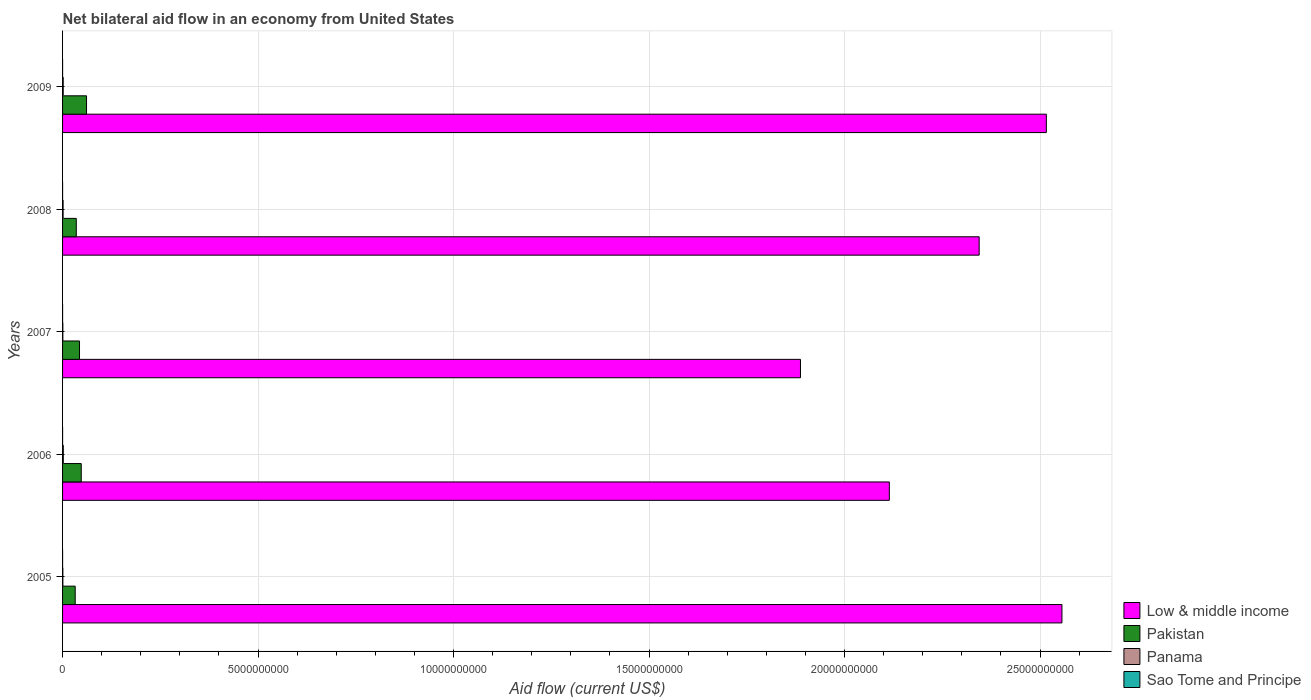Are the number of bars on each tick of the Y-axis equal?
Your answer should be very brief. Yes. How many bars are there on the 3rd tick from the top?
Keep it short and to the point. 4. What is the label of the 4th group of bars from the top?
Ensure brevity in your answer.  2006. In how many cases, is the number of bars for a given year not equal to the number of legend labels?
Your answer should be very brief. 0. What is the net bilateral aid flow in Pakistan in 2006?
Your answer should be very brief. 4.78e+08. Across all years, what is the maximum net bilateral aid flow in Sao Tome and Principe?
Make the answer very short. 4.60e+05. Across all years, what is the minimum net bilateral aid flow in Panama?
Offer a very short reply. 7.28e+06. In which year was the net bilateral aid flow in Sao Tome and Principe maximum?
Your answer should be compact. 2006. What is the total net bilateral aid flow in Sao Tome and Principe in the graph?
Your answer should be very brief. 1.44e+06. What is the difference between the net bilateral aid flow in Panama in 2005 and that in 2008?
Provide a short and direct response. -6.16e+06. What is the difference between the net bilateral aid flow in Low & middle income in 2009 and the net bilateral aid flow in Pakistan in 2008?
Make the answer very short. 2.48e+1. What is the average net bilateral aid flow in Low & middle income per year?
Offer a terse response. 2.28e+1. In the year 2005, what is the difference between the net bilateral aid flow in Pakistan and net bilateral aid flow in Panama?
Provide a succinct answer. 3.16e+08. In how many years, is the net bilateral aid flow in Pakistan greater than 21000000000 US$?
Keep it short and to the point. 0. What is the ratio of the net bilateral aid flow in Pakistan in 2006 to that in 2008?
Offer a very short reply. 1.36. Is the net bilateral aid flow in Panama in 2007 less than that in 2009?
Ensure brevity in your answer.  Yes. What is the difference between the highest and the second highest net bilateral aid flow in Pakistan?
Offer a terse response. 1.35e+08. In how many years, is the net bilateral aid flow in Low & middle income greater than the average net bilateral aid flow in Low & middle income taken over all years?
Your answer should be very brief. 3. What does the 1st bar from the top in 2009 represents?
Your response must be concise. Sao Tome and Principe. What does the 1st bar from the bottom in 2006 represents?
Your response must be concise. Low & middle income. Are all the bars in the graph horizontal?
Your response must be concise. Yes. How many years are there in the graph?
Provide a succinct answer. 5. What is the title of the graph?
Offer a very short reply. Net bilateral aid flow in an economy from United States. Does "Romania" appear as one of the legend labels in the graph?
Make the answer very short. No. What is the label or title of the Y-axis?
Give a very brief answer. Years. What is the Aid flow (current US$) of Low & middle income in 2005?
Your response must be concise. 2.56e+1. What is the Aid flow (current US$) of Pakistan in 2005?
Make the answer very short. 3.23e+08. What is the Aid flow (current US$) of Panama in 2005?
Provide a short and direct response. 7.50e+06. What is the Aid flow (current US$) in Sao Tome and Principe in 2005?
Your response must be concise. 1.40e+05. What is the Aid flow (current US$) in Low & middle income in 2006?
Ensure brevity in your answer.  2.11e+1. What is the Aid flow (current US$) of Pakistan in 2006?
Your answer should be compact. 4.78e+08. What is the Aid flow (current US$) of Panama in 2006?
Give a very brief answer. 1.87e+07. What is the Aid flow (current US$) in Low & middle income in 2007?
Give a very brief answer. 1.89e+1. What is the Aid flow (current US$) in Pakistan in 2007?
Offer a terse response. 4.34e+08. What is the Aid flow (current US$) in Panama in 2007?
Make the answer very short. 7.28e+06. What is the Aid flow (current US$) of Sao Tome and Principe in 2007?
Provide a short and direct response. 2.30e+05. What is the Aid flow (current US$) in Low & middle income in 2008?
Provide a short and direct response. 2.34e+1. What is the Aid flow (current US$) of Pakistan in 2008?
Give a very brief answer. 3.51e+08. What is the Aid flow (current US$) of Panama in 2008?
Provide a succinct answer. 1.37e+07. What is the Aid flow (current US$) in Low & middle income in 2009?
Offer a very short reply. 2.52e+1. What is the Aid flow (current US$) of Pakistan in 2009?
Your answer should be compact. 6.13e+08. What is the Aid flow (current US$) in Panama in 2009?
Provide a short and direct response. 1.67e+07. Across all years, what is the maximum Aid flow (current US$) in Low & middle income?
Ensure brevity in your answer.  2.56e+1. Across all years, what is the maximum Aid flow (current US$) of Pakistan?
Offer a terse response. 6.13e+08. Across all years, what is the maximum Aid flow (current US$) in Panama?
Your answer should be compact. 1.87e+07. Across all years, what is the minimum Aid flow (current US$) in Low & middle income?
Ensure brevity in your answer.  1.89e+1. Across all years, what is the minimum Aid flow (current US$) in Pakistan?
Make the answer very short. 3.23e+08. Across all years, what is the minimum Aid flow (current US$) of Panama?
Give a very brief answer. 7.28e+06. What is the total Aid flow (current US$) of Low & middle income in the graph?
Your answer should be very brief. 1.14e+11. What is the total Aid flow (current US$) in Pakistan in the graph?
Provide a succinct answer. 2.20e+09. What is the total Aid flow (current US$) of Panama in the graph?
Make the answer very short. 6.38e+07. What is the total Aid flow (current US$) in Sao Tome and Principe in the graph?
Give a very brief answer. 1.44e+06. What is the difference between the Aid flow (current US$) in Low & middle income in 2005 and that in 2006?
Your answer should be very brief. 4.41e+09. What is the difference between the Aid flow (current US$) of Pakistan in 2005 and that in 2006?
Ensure brevity in your answer.  -1.55e+08. What is the difference between the Aid flow (current US$) in Panama in 2005 and that in 2006?
Provide a short and direct response. -1.12e+07. What is the difference between the Aid flow (current US$) in Sao Tome and Principe in 2005 and that in 2006?
Make the answer very short. -3.20e+05. What is the difference between the Aid flow (current US$) of Low & middle income in 2005 and that in 2007?
Ensure brevity in your answer.  6.69e+09. What is the difference between the Aid flow (current US$) of Pakistan in 2005 and that in 2007?
Keep it short and to the point. -1.10e+08. What is the difference between the Aid flow (current US$) of Panama in 2005 and that in 2007?
Keep it short and to the point. 2.20e+05. What is the difference between the Aid flow (current US$) in Low & middle income in 2005 and that in 2008?
Your answer should be very brief. 2.12e+09. What is the difference between the Aid flow (current US$) of Pakistan in 2005 and that in 2008?
Make the answer very short. -2.76e+07. What is the difference between the Aid flow (current US$) of Panama in 2005 and that in 2008?
Your answer should be very brief. -6.16e+06. What is the difference between the Aid flow (current US$) of Low & middle income in 2005 and that in 2009?
Ensure brevity in your answer.  3.99e+08. What is the difference between the Aid flow (current US$) of Pakistan in 2005 and that in 2009?
Provide a short and direct response. -2.90e+08. What is the difference between the Aid flow (current US$) of Panama in 2005 and that in 2009?
Provide a short and direct response. -9.16e+06. What is the difference between the Aid flow (current US$) in Low & middle income in 2006 and that in 2007?
Provide a succinct answer. 2.27e+09. What is the difference between the Aid flow (current US$) in Pakistan in 2006 and that in 2007?
Ensure brevity in your answer.  4.42e+07. What is the difference between the Aid flow (current US$) of Panama in 2006 and that in 2007?
Provide a short and direct response. 1.14e+07. What is the difference between the Aid flow (current US$) of Low & middle income in 2006 and that in 2008?
Provide a succinct answer. -2.30e+09. What is the difference between the Aid flow (current US$) of Pakistan in 2006 and that in 2008?
Provide a succinct answer. 1.27e+08. What is the difference between the Aid flow (current US$) in Panama in 2006 and that in 2008?
Offer a very short reply. 5.07e+06. What is the difference between the Aid flow (current US$) in Low & middle income in 2006 and that in 2009?
Your answer should be very brief. -4.02e+09. What is the difference between the Aid flow (current US$) of Pakistan in 2006 and that in 2009?
Your answer should be compact. -1.35e+08. What is the difference between the Aid flow (current US$) of Panama in 2006 and that in 2009?
Provide a short and direct response. 2.07e+06. What is the difference between the Aid flow (current US$) of Sao Tome and Principe in 2006 and that in 2009?
Give a very brief answer. 6.00e+04. What is the difference between the Aid flow (current US$) of Low & middle income in 2007 and that in 2008?
Your response must be concise. -4.57e+09. What is the difference between the Aid flow (current US$) of Pakistan in 2007 and that in 2008?
Keep it short and to the point. 8.29e+07. What is the difference between the Aid flow (current US$) of Panama in 2007 and that in 2008?
Your response must be concise. -6.38e+06. What is the difference between the Aid flow (current US$) of Low & middle income in 2007 and that in 2009?
Your answer should be compact. -6.29e+09. What is the difference between the Aid flow (current US$) in Pakistan in 2007 and that in 2009?
Your answer should be compact. -1.79e+08. What is the difference between the Aid flow (current US$) of Panama in 2007 and that in 2009?
Your answer should be compact. -9.38e+06. What is the difference between the Aid flow (current US$) in Sao Tome and Principe in 2007 and that in 2009?
Provide a succinct answer. -1.70e+05. What is the difference between the Aid flow (current US$) in Low & middle income in 2008 and that in 2009?
Offer a very short reply. -1.72e+09. What is the difference between the Aid flow (current US$) of Pakistan in 2008 and that in 2009?
Your answer should be compact. -2.62e+08. What is the difference between the Aid flow (current US$) in Panama in 2008 and that in 2009?
Provide a succinct answer. -3.00e+06. What is the difference between the Aid flow (current US$) in Low & middle income in 2005 and the Aid flow (current US$) in Pakistan in 2006?
Provide a succinct answer. 2.51e+1. What is the difference between the Aid flow (current US$) of Low & middle income in 2005 and the Aid flow (current US$) of Panama in 2006?
Give a very brief answer. 2.55e+1. What is the difference between the Aid flow (current US$) of Low & middle income in 2005 and the Aid flow (current US$) of Sao Tome and Principe in 2006?
Make the answer very short. 2.56e+1. What is the difference between the Aid flow (current US$) in Pakistan in 2005 and the Aid flow (current US$) in Panama in 2006?
Your response must be concise. 3.04e+08. What is the difference between the Aid flow (current US$) of Pakistan in 2005 and the Aid flow (current US$) of Sao Tome and Principe in 2006?
Keep it short and to the point. 3.23e+08. What is the difference between the Aid flow (current US$) in Panama in 2005 and the Aid flow (current US$) in Sao Tome and Principe in 2006?
Give a very brief answer. 7.04e+06. What is the difference between the Aid flow (current US$) of Low & middle income in 2005 and the Aid flow (current US$) of Pakistan in 2007?
Ensure brevity in your answer.  2.51e+1. What is the difference between the Aid flow (current US$) of Low & middle income in 2005 and the Aid flow (current US$) of Panama in 2007?
Your answer should be very brief. 2.56e+1. What is the difference between the Aid flow (current US$) of Low & middle income in 2005 and the Aid flow (current US$) of Sao Tome and Principe in 2007?
Keep it short and to the point. 2.56e+1. What is the difference between the Aid flow (current US$) in Pakistan in 2005 and the Aid flow (current US$) in Panama in 2007?
Offer a terse response. 3.16e+08. What is the difference between the Aid flow (current US$) of Pakistan in 2005 and the Aid flow (current US$) of Sao Tome and Principe in 2007?
Offer a very short reply. 3.23e+08. What is the difference between the Aid flow (current US$) in Panama in 2005 and the Aid flow (current US$) in Sao Tome and Principe in 2007?
Your answer should be very brief. 7.27e+06. What is the difference between the Aid flow (current US$) of Low & middle income in 2005 and the Aid flow (current US$) of Pakistan in 2008?
Your response must be concise. 2.52e+1. What is the difference between the Aid flow (current US$) of Low & middle income in 2005 and the Aid flow (current US$) of Panama in 2008?
Provide a succinct answer. 2.55e+1. What is the difference between the Aid flow (current US$) of Low & middle income in 2005 and the Aid flow (current US$) of Sao Tome and Principe in 2008?
Your answer should be compact. 2.56e+1. What is the difference between the Aid flow (current US$) of Pakistan in 2005 and the Aid flow (current US$) of Panama in 2008?
Offer a terse response. 3.09e+08. What is the difference between the Aid flow (current US$) in Pakistan in 2005 and the Aid flow (current US$) in Sao Tome and Principe in 2008?
Make the answer very short. 3.23e+08. What is the difference between the Aid flow (current US$) of Panama in 2005 and the Aid flow (current US$) of Sao Tome and Principe in 2008?
Offer a terse response. 7.29e+06. What is the difference between the Aid flow (current US$) in Low & middle income in 2005 and the Aid flow (current US$) in Pakistan in 2009?
Your answer should be compact. 2.49e+1. What is the difference between the Aid flow (current US$) of Low & middle income in 2005 and the Aid flow (current US$) of Panama in 2009?
Your answer should be compact. 2.55e+1. What is the difference between the Aid flow (current US$) in Low & middle income in 2005 and the Aid flow (current US$) in Sao Tome and Principe in 2009?
Give a very brief answer. 2.56e+1. What is the difference between the Aid flow (current US$) of Pakistan in 2005 and the Aid flow (current US$) of Panama in 2009?
Make the answer very short. 3.06e+08. What is the difference between the Aid flow (current US$) in Pakistan in 2005 and the Aid flow (current US$) in Sao Tome and Principe in 2009?
Your answer should be very brief. 3.23e+08. What is the difference between the Aid flow (current US$) in Panama in 2005 and the Aid flow (current US$) in Sao Tome and Principe in 2009?
Keep it short and to the point. 7.10e+06. What is the difference between the Aid flow (current US$) of Low & middle income in 2006 and the Aid flow (current US$) of Pakistan in 2007?
Your answer should be compact. 2.07e+1. What is the difference between the Aid flow (current US$) of Low & middle income in 2006 and the Aid flow (current US$) of Panama in 2007?
Make the answer very short. 2.11e+1. What is the difference between the Aid flow (current US$) of Low & middle income in 2006 and the Aid flow (current US$) of Sao Tome and Principe in 2007?
Offer a very short reply. 2.11e+1. What is the difference between the Aid flow (current US$) in Pakistan in 2006 and the Aid flow (current US$) in Panama in 2007?
Keep it short and to the point. 4.70e+08. What is the difference between the Aid flow (current US$) in Pakistan in 2006 and the Aid flow (current US$) in Sao Tome and Principe in 2007?
Your answer should be very brief. 4.77e+08. What is the difference between the Aid flow (current US$) of Panama in 2006 and the Aid flow (current US$) of Sao Tome and Principe in 2007?
Your answer should be very brief. 1.85e+07. What is the difference between the Aid flow (current US$) of Low & middle income in 2006 and the Aid flow (current US$) of Pakistan in 2008?
Offer a very short reply. 2.08e+1. What is the difference between the Aid flow (current US$) of Low & middle income in 2006 and the Aid flow (current US$) of Panama in 2008?
Your answer should be compact. 2.11e+1. What is the difference between the Aid flow (current US$) in Low & middle income in 2006 and the Aid flow (current US$) in Sao Tome and Principe in 2008?
Give a very brief answer. 2.11e+1. What is the difference between the Aid flow (current US$) of Pakistan in 2006 and the Aid flow (current US$) of Panama in 2008?
Offer a very short reply. 4.64e+08. What is the difference between the Aid flow (current US$) of Pakistan in 2006 and the Aid flow (current US$) of Sao Tome and Principe in 2008?
Make the answer very short. 4.78e+08. What is the difference between the Aid flow (current US$) of Panama in 2006 and the Aid flow (current US$) of Sao Tome and Principe in 2008?
Your answer should be very brief. 1.85e+07. What is the difference between the Aid flow (current US$) in Low & middle income in 2006 and the Aid flow (current US$) in Pakistan in 2009?
Make the answer very short. 2.05e+1. What is the difference between the Aid flow (current US$) of Low & middle income in 2006 and the Aid flow (current US$) of Panama in 2009?
Provide a short and direct response. 2.11e+1. What is the difference between the Aid flow (current US$) of Low & middle income in 2006 and the Aid flow (current US$) of Sao Tome and Principe in 2009?
Keep it short and to the point. 2.11e+1. What is the difference between the Aid flow (current US$) of Pakistan in 2006 and the Aid flow (current US$) of Panama in 2009?
Offer a terse response. 4.61e+08. What is the difference between the Aid flow (current US$) in Pakistan in 2006 and the Aid flow (current US$) in Sao Tome and Principe in 2009?
Provide a succinct answer. 4.77e+08. What is the difference between the Aid flow (current US$) in Panama in 2006 and the Aid flow (current US$) in Sao Tome and Principe in 2009?
Your response must be concise. 1.83e+07. What is the difference between the Aid flow (current US$) of Low & middle income in 2007 and the Aid flow (current US$) of Pakistan in 2008?
Your answer should be compact. 1.85e+1. What is the difference between the Aid flow (current US$) in Low & middle income in 2007 and the Aid flow (current US$) in Panama in 2008?
Offer a terse response. 1.89e+1. What is the difference between the Aid flow (current US$) of Low & middle income in 2007 and the Aid flow (current US$) of Sao Tome and Principe in 2008?
Provide a short and direct response. 1.89e+1. What is the difference between the Aid flow (current US$) in Pakistan in 2007 and the Aid flow (current US$) in Panama in 2008?
Provide a succinct answer. 4.20e+08. What is the difference between the Aid flow (current US$) in Pakistan in 2007 and the Aid flow (current US$) in Sao Tome and Principe in 2008?
Make the answer very short. 4.33e+08. What is the difference between the Aid flow (current US$) in Panama in 2007 and the Aid flow (current US$) in Sao Tome and Principe in 2008?
Your response must be concise. 7.07e+06. What is the difference between the Aid flow (current US$) in Low & middle income in 2007 and the Aid flow (current US$) in Pakistan in 2009?
Provide a short and direct response. 1.83e+1. What is the difference between the Aid flow (current US$) of Low & middle income in 2007 and the Aid flow (current US$) of Panama in 2009?
Provide a short and direct response. 1.89e+1. What is the difference between the Aid flow (current US$) of Low & middle income in 2007 and the Aid flow (current US$) of Sao Tome and Principe in 2009?
Provide a short and direct response. 1.89e+1. What is the difference between the Aid flow (current US$) in Pakistan in 2007 and the Aid flow (current US$) in Panama in 2009?
Keep it short and to the point. 4.17e+08. What is the difference between the Aid flow (current US$) of Pakistan in 2007 and the Aid flow (current US$) of Sao Tome and Principe in 2009?
Your response must be concise. 4.33e+08. What is the difference between the Aid flow (current US$) of Panama in 2007 and the Aid flow (current US$) of Sao Tome and Principe in 2009?
Ensure brevity in your answer.  6.88e+06. What is the difference between the Aid flow (current US$) in Low & middle income in 2008 and the Aid flow (current US$) in Pakistan in 2009?
Ensure brevity in your answer.  2.28e+1. What is the difference between the Aid flow (current US$) in Low & middle income in 2008 and the Aid flow (current US$) in Panama in 2009?
Make the answer very short. 2.34e+1. What is the difference between the Aid flow (current US$) of Low & middle income in 2008 and the Aid flow (current US$) of Sao Tome and Principe in 2009?
Give a very brief answer. 2.34e+1. What is the difference between the Aid flow (current US$) of Pakistan in 2008 and the Aid flow (current US$) of Panama in 2009?
Your response must be concise. 3.34e+08. What is the difference between the Aid flow (current US$) of Pakistan in 2008 and the Aid flow (current US$) of Sao Tome and Principe in 2009?
Your answer should be very brief. 3.50e+08. What is the difference between the Aid flow (current US$) of Panama in 2008 and the Aid flow (current US$) of Sao Tome and Principe in 2009?
Give a very brief answer. 1.33e+07. What is the average Aid flow (current US$) in Low & middle income per year?
Your answer should be compact. 2.28e+1. What is the average Aid flow (current US$) of Pakistan per year?
Your answer should be compact. 4.40e+08. What is the average Aid flow (current US$) in Panama per year?
Give a very brief answer. 1.28e+07. What is the average Aid flow (current US$) in Sao Tome and Principe per year?
Ensure brevity in your answer.  2.88e+05. In the year 2005, what is the difference between the Aid flow (current US$) in Low & middle income and Aid flow (current US$) in Pakistan?
Keep it short and to the point. 2.52e+1. In the year 2005, what is the difference between the Aid flow (current US$) of Low & middle income and Aid flow (current US$) of Panama?
Give a very brief answer. 2.56e+1. In the year 2005, what is the difference between the Aid flow (current US$) in Low & middle income and Aid flow (current US$) in Sao Tome and Principe?
Give a very brief answer. 2.56e+1. In the year 2005, what is the difference between the Aid flow (current US$) in Pakistan and Aid flow (current US$) in Panama?
Your response must be concise. 3.16e+08. In the year 2005, what is the difference between the Aid flow (current US$) in Pakistan and Aid flow (current US$) in Sao Tome and Principe?
Provide a short and direct response. 3.23e+08. In the year 2005, what is the difference between the Aid flow (current US$) of Panama and Aid flow (current US$) of Sao Tome and Principe?
Your answer should be very brief. 7.36e+06. In the year 2006, what is the difference between the Aid flow (current US$) in Low & middle income and Aid flow (current US$) in Pakistan?
Provide a short and direct response. 2.07e+1. In the year 2006, what is the difference between the Aid flow (current US$) of Low & middle income and Aid flow (current US$) of Panama?
Offer a terse response. 2.11e+1. In the year 2006, what is the difference between the Aid flow (current US$) of Low & middle income and Aid flow (current US$) of Sao Tome and Principe?
Keep it short and to the point. 2.11e+1. In the year 2006, what is the difference between the Aid flow (current US$) in Pakistan and Aid flow (current US$) in Panama?
Your response must be concise. 4.59e+08. In the year 2006, what is the difference between the Aid flow (current US$) in Pakistan and Aid flow (current US$) in Sao Tome and Principe?
Make the answer very short. 4.77e+08. In the year 2006, what is the difference between the Aid flow (current US$) in Panama and Aid flow (current US$) in Sao Tome and Principe?
Offer a very short reply. 1.83e+07. In the year 2007, what is the difference between the Aid flow (current US$) of Low & middle income and Aid flow (current US$) of Pakistan?
Your answer should be compact. 1.84e+1. In the year 2007, what is the difference between the Aid flow (current US$) of Low & middle income and Aid flow (current US$) of Panama?
Ensure brevity in your answer.  1.89e+1. In the year 2007, what is the difference between the Aid flow (current US$) of Low & middle income and Aid flow (current US$) of Sao Tome and Principe?
Ensure brevity in your answer.  1.89e+1. In the year 2007, what is the difference between the Aid flow (current US$) in Pakistan and Aid flow (current US$) in Panama?
Keep it short and to the point. 4.26e+08. In the year 2007, what is the difference between the Aid flow (current US$) of Pakistan and Aid flow (current US$) of Sao Tome and Principe?
Make the answer very short. 4.33e+08. In the year 2007, what is the difference between the Aid flow (current US$) in Panama and Aid flow (current US$) in Sao Tome and Principe?
Ensure brevity in your answer.  7.05e+06. In the year 2008, what is the difference between the Aid flow (current US$) in Low & middle income and Aid flow (current US$) in Pakistan?
Ensure brevity in your answer.  2.31e+1. In the year 2008, what is the difference between the Aid flow (current US$) in Low & middle income and Aid flow (current US$) in Panama?
Your answer should be compact. 2.34e+1. In the year 2008, what is the difference between the Aid flow (current US$) in Low & middle income and Aid flow (current US$) in Sao Tome and Principe?
Your response must be concise. 2.34e+1. In the year 2008, what is the difference between the Aid flow (current US$) in Pakistan and Aid flow (current US$) in Panama?
Provide a succinct answer. 3.37e+08. In the year 2008, what is the difference between the Aid flow (current US$) of Pakistan and Aid flow (current US$) of Sao Tome and Principe?
Your answer should be very brief. 3.50e+08. In the year 2008, what is the difference between the Aid flow (current US$) in Panama and Aid flow (current US$) in Sao Tome and Principe?
Your answer should be compact. 1.34e+07. In the year 2009, what is the difference between the Aid flow (current US$) in Low & middle income and Aid flow (current US$) in Pakistan?
Provide a short and direct response. 2.45e+1. In the year 2009, what is the difference between the Aid flow (current US$) of Low & middle income and Aid flow (current US$) of Panama?
Your answer should be compact. 2.51e+1. In the year 2009, what is the difference between the Aid flow (current US$) in Low & middle income and Aid flow (current US$) in Sao Tome and Principe?
Provide a succinct answer. 2.52e+1. In the year 2009, what is the difference between the Aid flow (current US$) in Pakistan and Aid flow (current US$) in Panama?
Ensure brevity in your answer.  5.96e+08. In the year 2009, what is the difference between the Aid flow (current US$) of Pakistan and Aid flow (current US$) of Sao Tome and Principe?
Offer a very short reply. 6.13e+08. In the year 2009, what is the difference between the Aid flow (current US$) of Panama and Aid flow (current US$) of Sao Tome and Principe?
Keep it short and to the point. 1.63e+07. What is the ratio of the Aid flow (current US$) in Low & middle income in 2005 to that in 2006?
Your response must be concise. 1.21. What is the ratio of the Aid flow (current US$) of Pakistan in 2005 to that in 2006?
Ensure brevity in your answer.  0.68. What is the ratio of the Aid flow (current US$) of Panama in 2005 to that in 2006?
Make the answer very short. 0.4. What is the ratio of the Aid flow (current US$) in Sao Tome and Principe in 2005 to that in 2006?
Give a very brief answer. 0.3. What is the ratio of the Aid flow (current US$) of Low & middle income in 2005 to that in 2007?
Give a very brief answer. 1.35. What is the ratio of the Aid flow (current US$) of Pakistan in 2005 to that in 2007?
Provide a short and direct response. 0.75. What is the ratio of the Aid flow (current US$) in Panama in 2005 to that in 2007?
Your response must be concise. 1.03. What is the ratio of the Aid flow (current US$) in Sao Tome and Principe in 2005 to that in 2007?
Ensure brevity in your answer.  0.61. What is the ratio of the Aid flow (current US$) of Low & middle income in 2005 to that in 2008?
Provide a short and direct response. 1.09. What is the ratio of the Aid flow (current US$) in Pakistan in 2005 to that in 2008?
Offer a terse response. 0.92. What is the ratio of the Aid flow (current US$) in Panama in 2005 to that in 2008?
Offer a terse response. 0.55. What is the ratio of the Aid flow (current US$) in Sao Tome and Principe in 2005 to that in 2008?
Offer a very short reply. 0.67. What is the ratio of the Aid flow (current US$) in Low & middle income in 2005 to that in 2009?
Your response must be concise. 1.02. What is the ratio of the Aid flow (current US$) in Pakistan in 2005 to that in 2009?
Provide a succinct answer. 0.53. What is the ratio of the Aid flow (current US$) of Panama in 2005 to that in 2009?
Give a very brief answer. 0.45. What is the ratio of the Aid flow (current US$) of Sao Tome and Principe in 2005 to that in 2009?
Your response must be concise. 0.35. What is the ratio of the Aid flow (current US$) in Low & middle income in 2006 to that in 2007?
Ensure brevity in your answer.  1.12. What is the ratio of the Aid flow (current US$) in Pakistan in 2006 to that in 2007?
Your answer should be very brief. 1.1. What is the ratio of the Aid flow (current US$) in Panama in 2006 to that in 2007?
Your answer should be very brief. 2.57. What is the ratio of the Aid flow (current US$) in Low & middle income in 2006 to that in 2008?
Ensure brevity in your answer.  0.9. What is the ratio of the Aid flow (current US$) of Pakistan in 2006 to that in 2008?
Offer a very short reply. 1.36. What is the ratio of the Aid flow (current US$) in Panama in 2006 to that in 2008?
Your answer should be compact. 1.37. What is the ratio of the Aid flow (current US$) in Sao Tome and Principe in 2006 to that in 2008?
Keep it short and to the point. 2.19. What is the ratio of the Aid flow (current US$) of Low & middle income in 2006 to that in 2009?
Keep it short and to the point. 0.84. What is the ratio of the Aid flow (current US$) of Pakistan in 2006 to that in 2009?
Offer a terse response. 0.78. What is the ratio of the Aid flow (current US$) of Panama in 2006 to that in 2009?
Provide a short and direct response. 1.12. What is the ratio of the Aid flow (current US$) in Sao Tome and Principe in 2006 to that in 2009?
Provide a short and direct response. 1.15. What is the ratio of the Aid flow (current US$) of Low & middle income in 2007 to that in 2008?
Make the answer very short. 0.81. What is the ratio of the Aid flow (current US$) in Pakistan in 2007 to that in 2008?
Make the answer very short. 1.24. What is the ratio of the Aid flow (current US$) of Panama in 2007 to that in 2008?
Make the answer very short. 0.53. What is the ratio of the Aid flow (current US$) in Sao Tome and Principe in 2007 to that in 2008?
Give a very brief answer. 1.1. What is the ratio of the Aid flow (current US$) of Low & middle income in 2007 to that in 2009?
Make the answer very short. 0.75. What is the ratio of the Aid flow (current US$) of Pakistan in 2007 to that in 2009?
Your answer should be very brief. 0.71. What is the ratio of the Aid flow (current US$) of Panama in 2007 to that in 2009?
Ensure brevity in your answer.  0.44. What is the ratio of the Aid flow (current US$) in Sao Tome and Principe in 2007 to that in 2009?
Give a very brief answer. 0.57. What is the ratio of the Aid flow (current US$) of Low & middle income in 2008 to that in 2009?
Your answer should be compact. 0.93. What is the ratio of the Aid flow (current US$) of Pakistan in 2008 to that in 2009?
Offer a terse response. 0.57. What is the ratio of the Aid flow (current US$) of Panama in 2008 to that in 2009?
Make the answer very short. 0.82. What is the ratio of the Aid flow (current US$) of Sao Tome and Principe in 2008 to that in 2009?
Keep it short and to the point. 0.53. What is the difference between the highest and the second highest Aid flow (current US$) of Low & middle income?
Ensure brevity in your answer.  3.99e+08. What is the difference between the highest and the second highest Aid flow (current US$) in Pakistan?
Offer a terse response. 1.35e+08. What is the difference between the highest and the second highest Aid flow (current US$) of Panama?
Your answer should be very brief. 2.07e+06. What is the difference between the highest and the second highest Aid flow (current US$) of Sao Tome and Principe?
Provide a short and direct response. 6.00e+04. What is the difference between the highest and the lowest Aid flow (current US$) in Low & middle income?
Your answer should be very brief. 6.69e+09. What is the difference between the highest and the lowest Aid flow (current US$) of Pakistan?
Ensure brevity in your answer.  2.90e+08. What is the difference between the highest and the lowest Aid flow (current US$) of Panama?
Keep it short and to the point. 1.14e+07. 